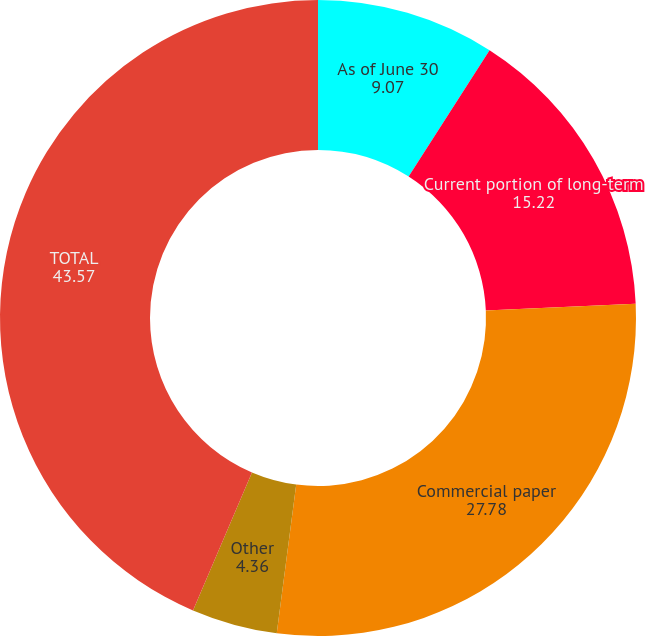<chart> <loc_0><loc_0><loc_500><loc_500><pie_chart><fcel>As of June 30<fcel>Current portion of long-term<fcel>Commercial paper<fcel>Other<fcel>TOTAL<fcel>Short-term weighted average<nl><fcel>9.07%<fcel>15.22%<fcel>27.78%<fcel>4.36%<fcel>43.57%<fcel>0.0%<nl></chart> 